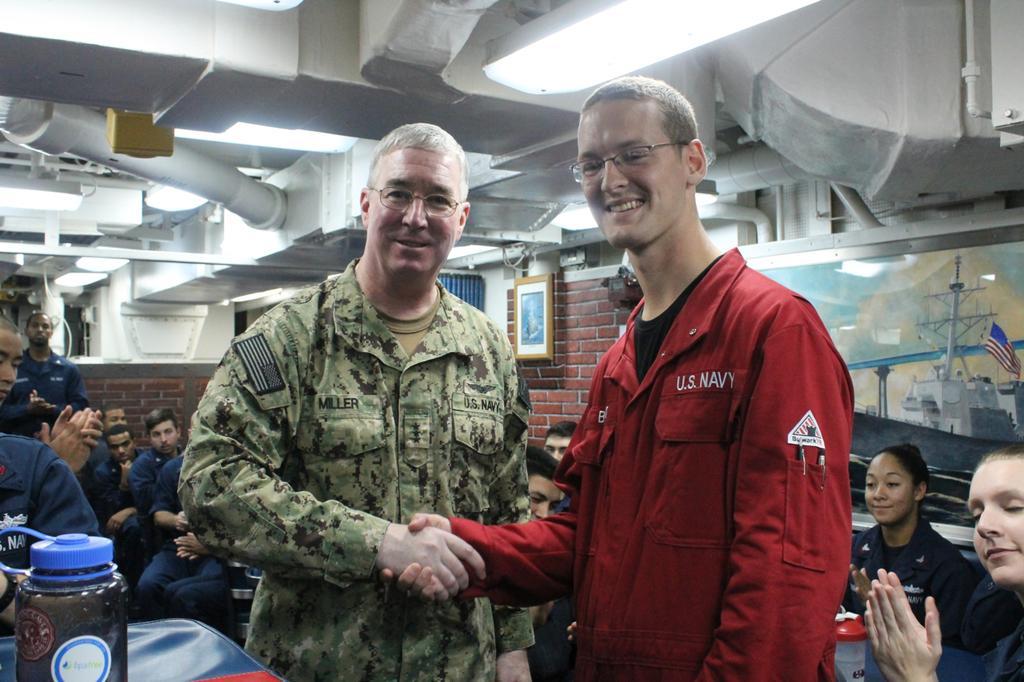Can you describe this image briefly? In this image we can see a few people, among them some are sitting and standing, around them there are some objects, on the top we can see few pipes and lights. 